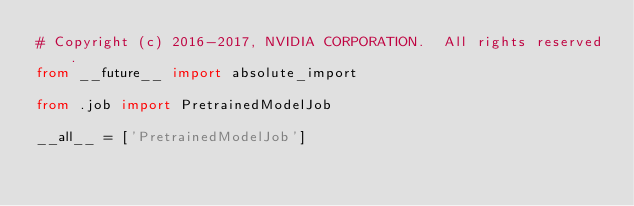Convert code to text. <code><loc_0><loc_0><loc_500><loc_500><_Python_># Copyright (c) 2016-2017, NVIDIA CORPORATION.  All rights reserved.
from __future__ import absolute_import

from .job import PretrainedModelJob

__all__ = ['PretrainedModelJob']
</code> 